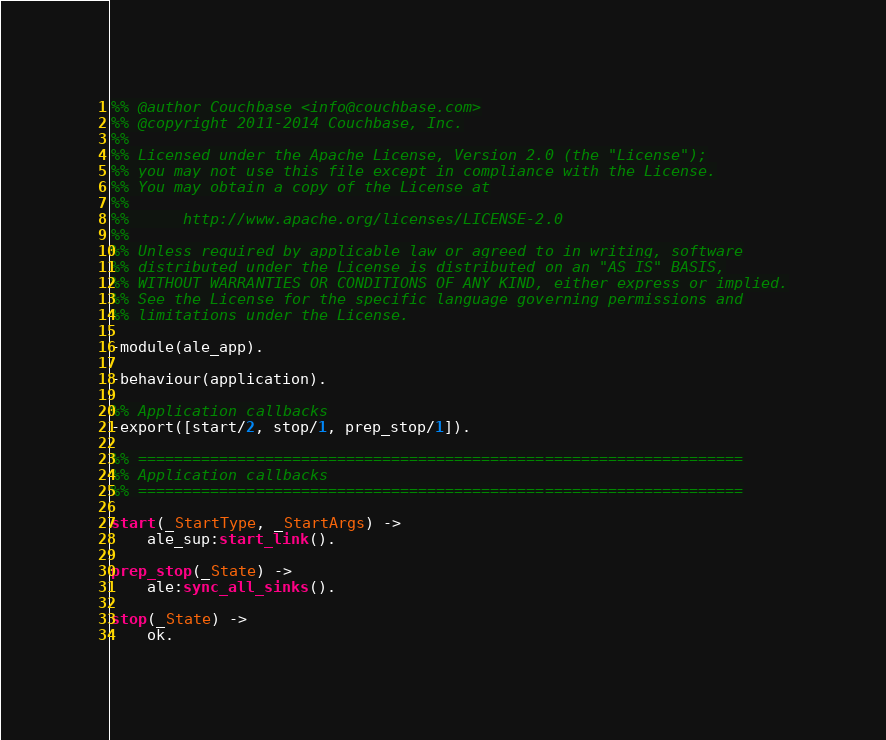Convert code to text. <code><loc_0><loc_0><loc_500><loc_500><_Erlang_>%% @author Couchbase <info@couchbase.com>
%% @copyright 2011-2014 Couchbase, Inc.
%%
%% Licensed under the Apache License, Version 2.0 (the "License");
%% you may not use this file except in compliance with the License.
%% You may obtain a copy of the License at
%%
%%      http://www.apache.org/licenses/LICENSE-2.0
%%
%% Unless required by applicable law or agreed to in writing, software
%% distributed under the License is distributed on an "AS IS" BASIS,
%% WITHOUT WARRANTIES OR CONDITIONS OF ANY KIND, either express or implied.
%% See the License for the specific language governing permissions and
%% limitations under the License.

-module(ale_app).

-behaviour(application).

%% Application callbacks
-export([start/2, stop/1, prep_stop/1]).

%% ===================================================================
%% Application callbacks
%% ===================================================================

start(_StartType, _StartArgs) ->
    ale_sup:start_link().

prep_stop(_State) ->
    ale:sync_all_sinks().

stop(_State) ->
    ok.
</code> 